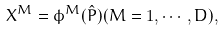Convert formula to latex. <formula><loc_0><loc_0><loc_500><loc_500>X ^ { M } = \phi ^ { M } ( \hat { P } ) ( M = 1 , \cdots , D ) ,</formula> 